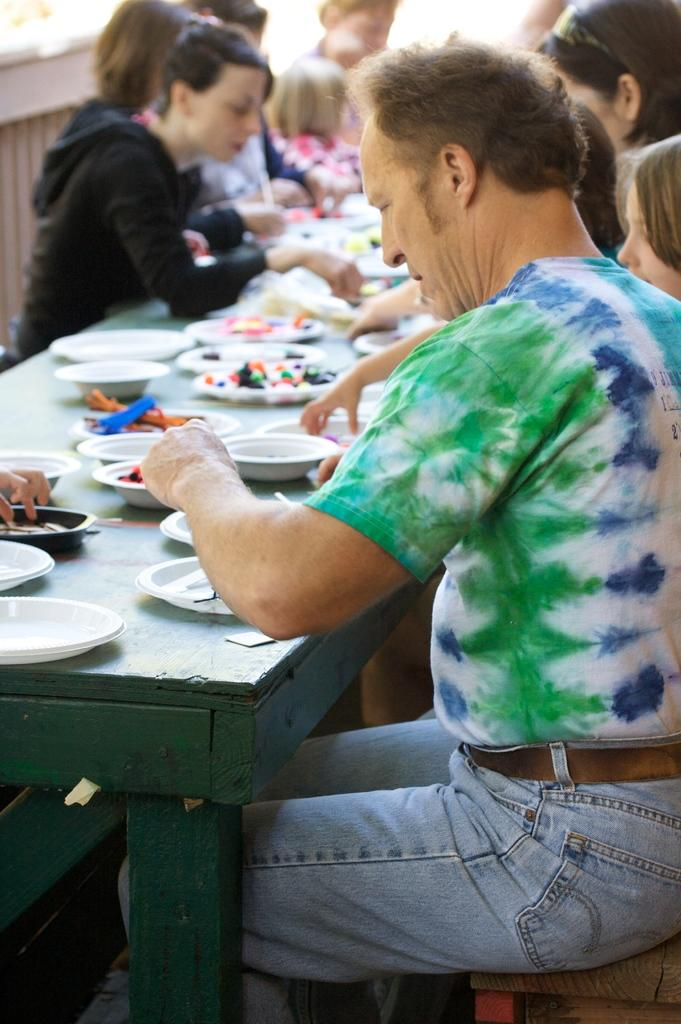What is happening in the image? There are people sitting around a table in the image. What can be seen on the table? There are many plates with food items on the table. How many worms can be seen crawling on the glass in the image? There are no worms or glass present in the image. 